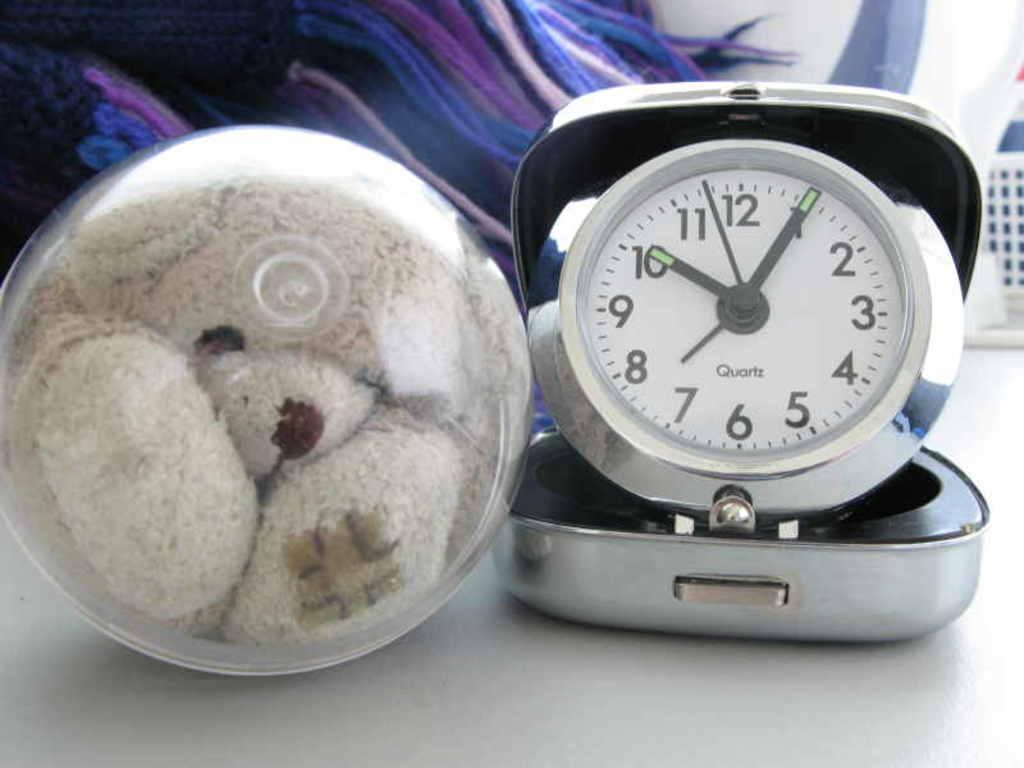<image>
Summarize the visual content of the image. Teddybear next to a clock from Quartz brand. 